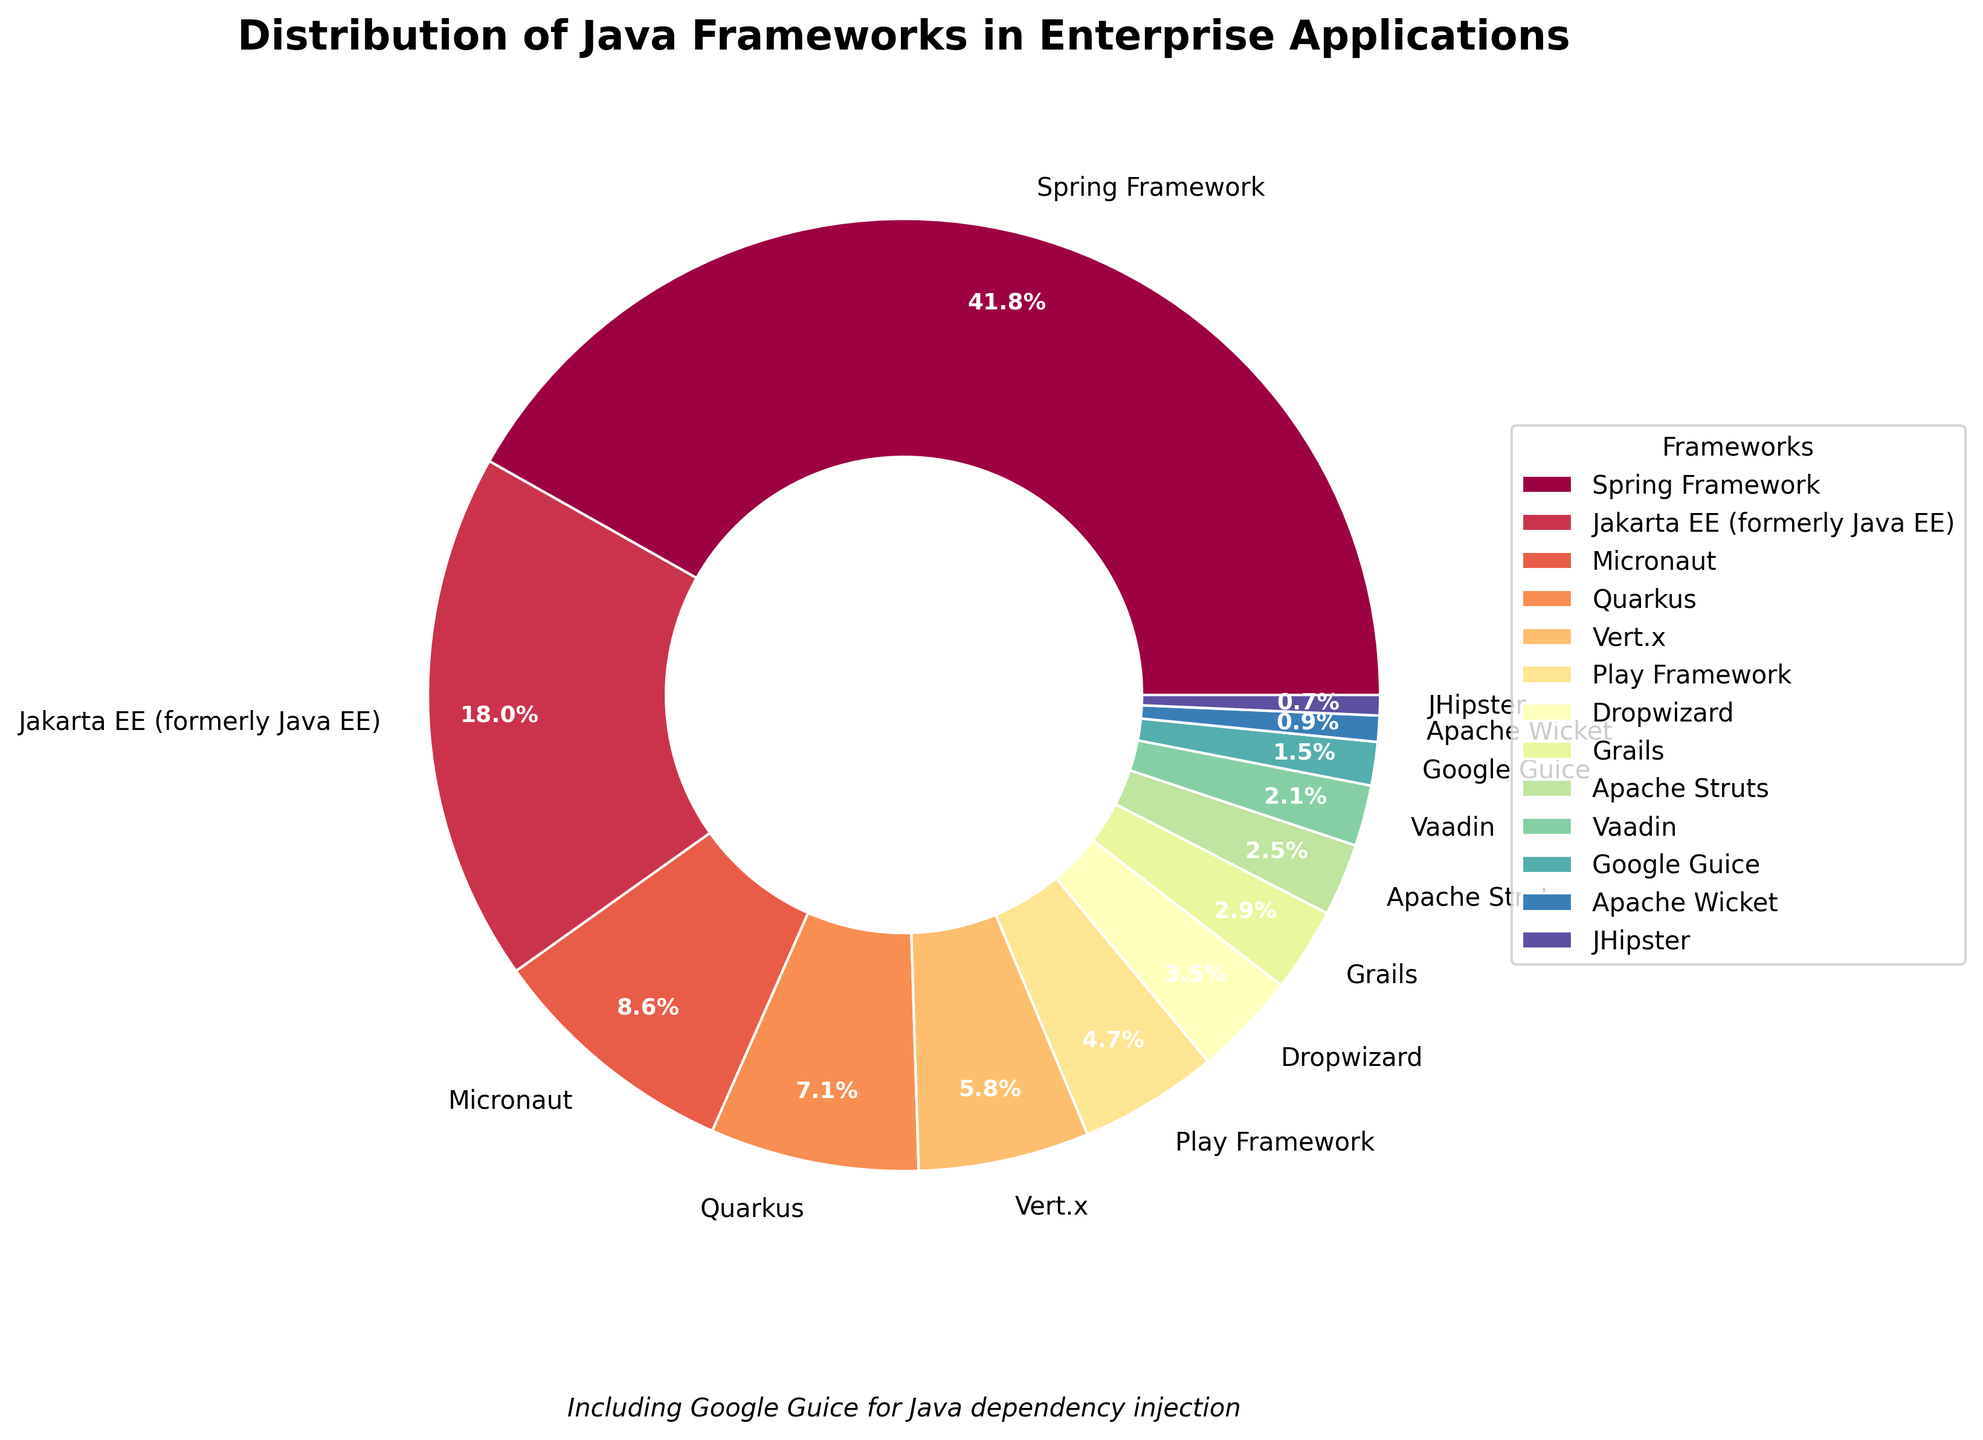Which framework has the largest share in enterprise applications? The framework with the largest share in the pie chart is visually the largest segment. Looking closely, it's easy to see that the Spring Framework has the largest share.
Answer: Spring Framework Which framework has the smallest share? The framework with the smallest share is visually the smallest segment in the pie chart. The smallest segment belongs to JHipster.
Answer: JHipster How much larger is Spring Framework's share compared to Jakarta EE? To find out how much larger Spring Framework's share is compared to Jakarta EE, subtract Jakarta EE’s share from Spring Framework’s share: 42.5% - 18.3% = 24.2%.
Answer: 24.2% Which two frameworks have a combined share close to 15%? By identifying and summing the percentages of two frameworks to see which combined share is close to 15%, we find that Vert.x (5.9%) and Play Framework (4.8%) combined give us 10.7%, while Quarkus (7.2%) and Micronaut (8.7%) give us 15.9%. So the combination that is the closest to 15% is Quarkus and Micronaut.
Answer: Quarkus and Micronaut Which frameworks have a share greater than 5% but less than 10%? To find frameworks with shares between 5% and 10%, visually scan the segments and their labels. The frameworks that meet this criterion are Micronaut (8.7%), Quarkus (7.2%), and Vert.x (5.9%).
Answer: Micronaut, Quarkus, Vert.x How does the percentage of Google Guice compare with Apache Struts? Look at the labeled segments for Google Guice and Apache Struts. Google Guice has a 1.5% share, while Apache Struts has a 2.5% share. We see that Apache Struts has a larger percentage compared to Google Guice.
Answer: Apache Struts has a larger percentage Which frameworks have a total share of less than 20%? Sum the percentages of frameworks until the cumulative share is less than 20%. The frameworks with their shares adding up to less than 20% are Vert.x (5.9%), Play Framework (4.8%), Dropwizard (3.6%), Grails (2.9%), Apache Struts (2.5%). The sum is: 5.9 + 4.8 + 3.6 + 2.9 + 2.5 = 19.7%. So these frameworks have a total share of less than 20%.
Answer: Vert.x, Play Framework, Dropwizard, Grails, Apache Struts What is the combined percentage of the three least used frameworks? Identify the three least used frameworks by locating the smallest segments on the pie chart: Apache Wicket (0.9%), JHipster (0.7%), and Google Guice (1.5%). Add their percentages: 0.9% + 0.7% + 1.5% = 3.1%.
Answer: 3.1% Which framework is almost twice as popular as Play Framework? Look at the labels and percentages. Play Framework has a share of 4.8%. A framework that is almost twice this share would be around 9.6%. Micronaut has a share of 8.7%, which is close to being twice as popular.
Answer: Micronaut 